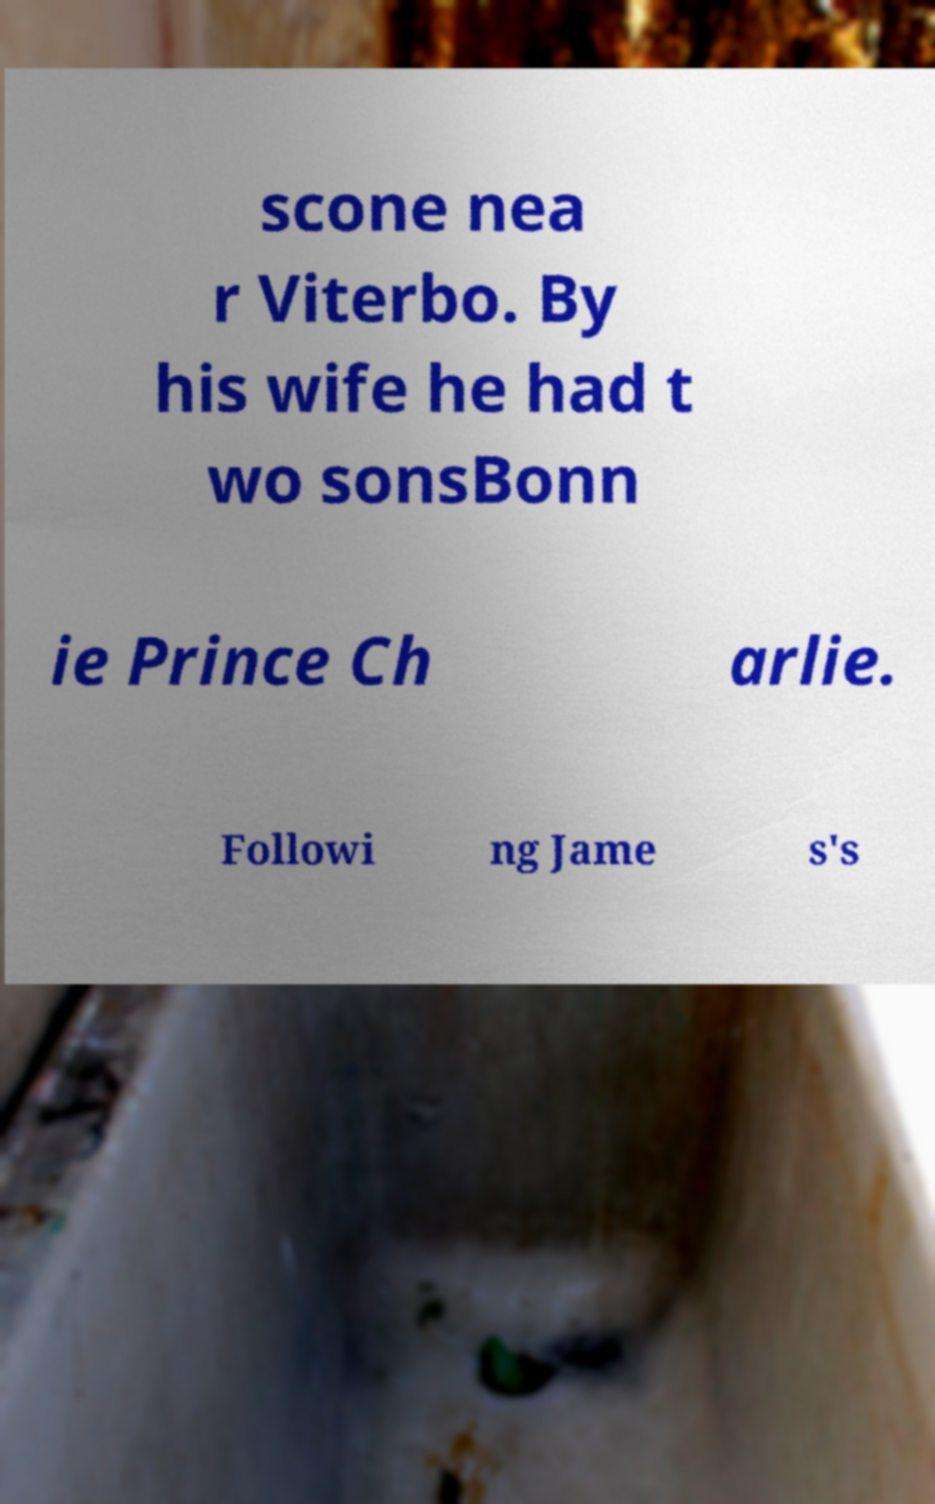There's text embedded in this image that I need extracted. Can you transcribe it verbatim? scone nea r Viterbo. By his wife he had t wo sonsBonn ie Prince Ch arlie. Followi ng Jame s's 